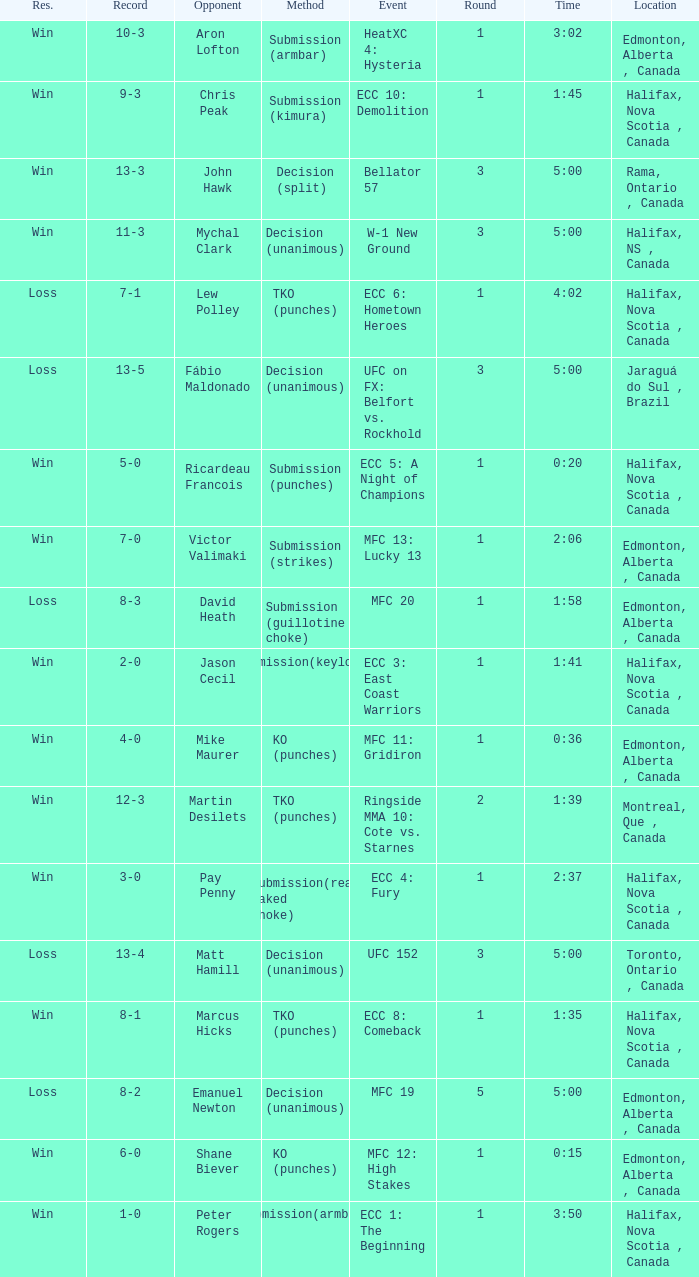What is the location of the match with an event of ecc 8: comeback? Halifax, Nova Scotia , Canada. 